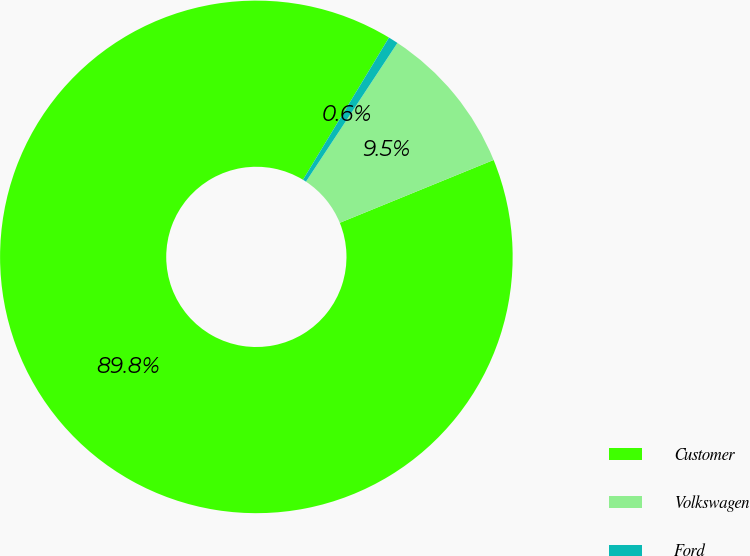Convert chart to OTSL. <chart><loc_0><loc_0><loc_500><loc_500><pie_chart><fcel>Customer<fcel>Volkswagen<fcel>Ford<nl><fcel>89.83%<fcel>9.55%<fcel>0.62%<nl></chart> 